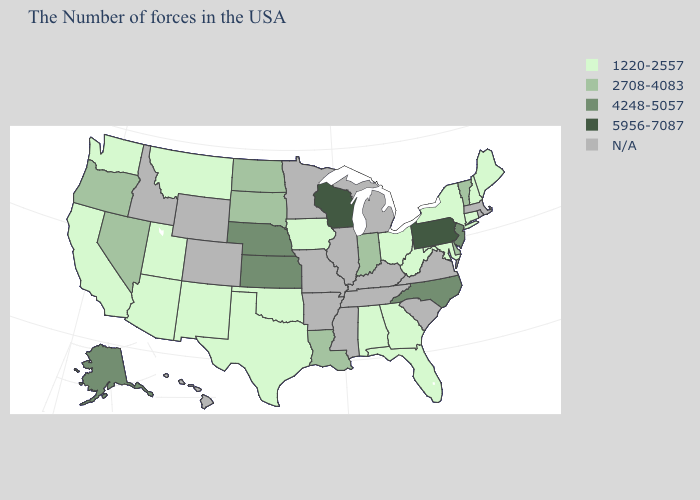What is the value of Illinois?
Keep it brief. N/A. Does the first symbol in the legend represent the smallest category?
Be succinct. Yes. Name the states that have a value in the range 2708-4083?
Quick response, please. Vermont, Delaware, Indiana, Louisiana, South Dakota, North Dakota, Nevada, Oregon. Name the states that have a value in the range N/A?
Quick response, please. Massachusetts, Rhode Island, Virginia, South Carolina, Michigan, Kentucky, Tennessee, Illinois, Mississippi, Missouri, Arkansas, Minnesota, Wyoming, Colorado, Idaho, Hawaii. Name the states that have a value in the range 2708-4083?
Concise answer only. Vermont, Delaware, Indiana, Louisiana, South Dakota, North Dakota, Nevada, Oregon. Name the states that have a value in the range 4248-5057?
Give a very brief answer. New Jersey, North Carolina, Kansas, Nebraska, Alaska. Which states have the lowest value in the USA?
Quick response, please. Maine, New Hampshire, Connecticut, New York, Maryland, West Virginia, Ohio, Florida, Georgia, Alabama, Iowa, Oklahoma, Texas, New Mexico, Utah, Montana, Arizona, California, Washington. Name the states that have a value in the range 4248-5057?
Write a very short answer. New Jersey, North Carolina, Kansas, Nebraska, Alaska. What is the value of Wisconsin?
Short answer required. 5956-7087. Name the states that have a value in the range N/A?
Keep it brief. Massachusetts, Rhode Island, Virginia, South Carolina, Michigan, Kentucky, Tennessee, Illinois, Mississippi, Missouri, Arkansas, Minnesota, Wyoming, Colorado, Idaho, Hawaii. Which states hav the highest value in the West?
Short answer required. Alaska. What is the lowest value in the West?
Give a very brief answer. 1220-2557. Name the states that have a value in the range 1220-2557?
Short answer required. Maine, New Hampshire, Connecticut, New York, Maryland, West Virginia, Ohio, Florida, Georgia, Alabama, Iowa, Oklahoma, Texas, New Mexico, Utah, Montana, Arizona, California, Washington. 